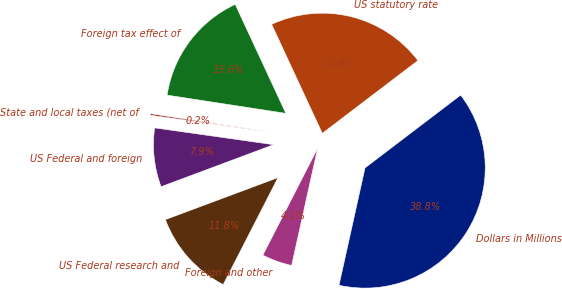Convert chart. <chart><loc_0><loc_0><loc_500><loc_500><pie_chart><fcel>Dollars in Millions<fcel>US statutory rate<fcel>Foreign tax effect of<fcel>State and local taxes (net of<fcel>US Federal and foreign<fcel>US Federal research and<fcel>Foreign and other<nl><fcel>38.83%<fcel>21.57%<fcel>15.65%<fcel>0.19%<fcel>7.92%<fcel>11.78%<fcel>4.06%<nl></chart> 